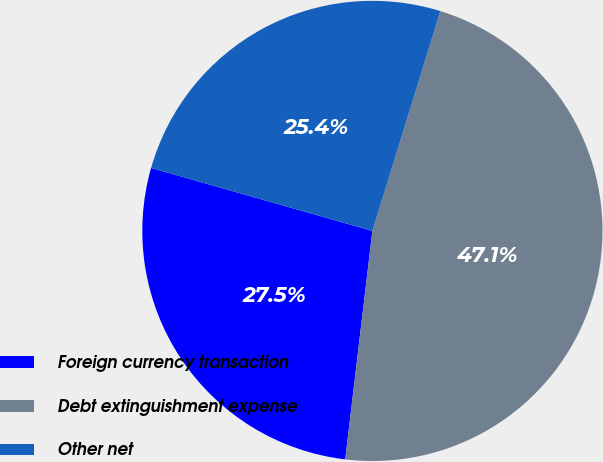<chart> <loc_0><loc_0><loc_500><loc_500><pie_chart><fcel>Foreign currency transaction<fcel>Debt extinguishment expense<fcel>Other net<nl><fcel>27.53%<fcel>47.11%<fcel>25.36%<nl></chart> 